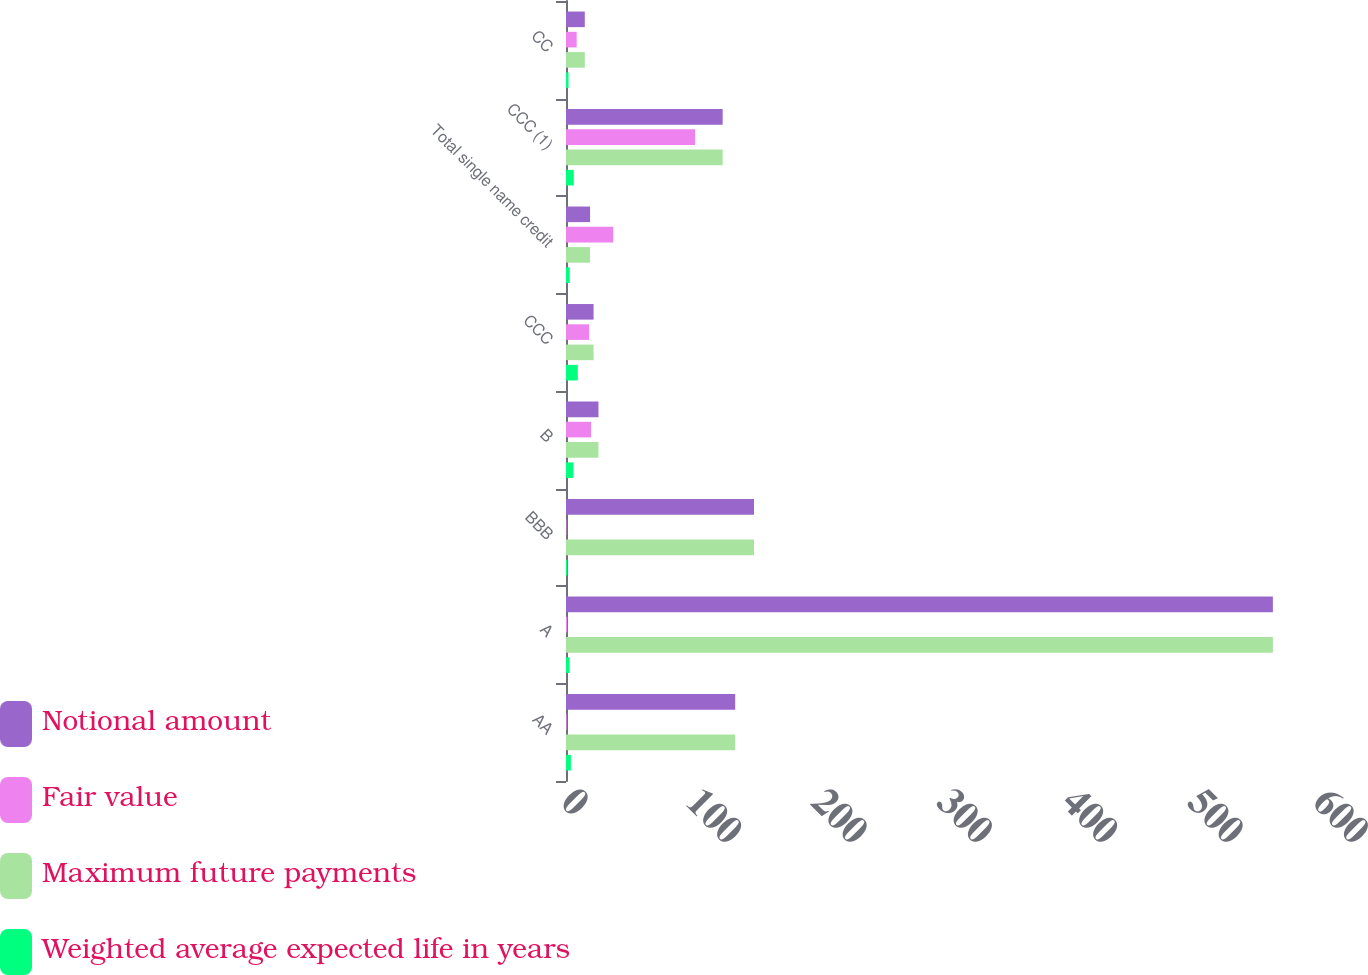Convert chart. <chart><loc_0><loc_0><loc_500><loc_500><stacked_bar_chart><ecel><fcel>AA<fcel>A<fcel>BBB<fcel>B<fcel>CCC<fcel>Total single name credit<fcel>CCC (1)<fcel>CC<nl><fcel>Notional amount<fcel>135<fcel>564<fcel>150<fcel>25.9<fcel>22<fcel>19.2<fcel>125<fcel>15<nl><fcel>Fair value<fcel>0.5<fcel>0.9<fcel>0.3<fcel>20<fcel>18.4<fcel>37.7<fcel>103<fcel>8.5<nl><fcel>Maximum future payments<fcel>135<fcel>564<fcel>150<fcel>25.9<fcel>22<fcel>19.2<fcel>125<fcel>15<nl><fcel>Weighted average expected life in years<fcel>3.9<fcel>2.9<fcel>1.1<fcel>5.9<fcel>9.4<fcel>3<fcel>6.2<fcel>2<nl></chart> 